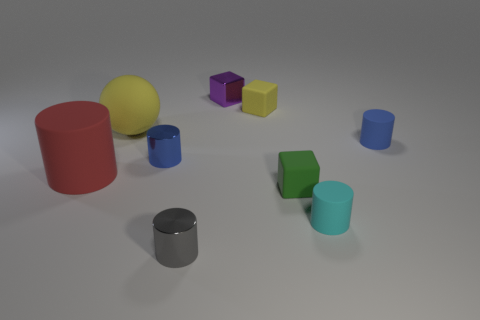There is a yellow matte thing that is in front of the tiny matte block that is behind the cylinder that is on the left side of the yellow sphere; how big is it? The yellow matte object in question appears to be of medium size compared to the other objects in the image, specifically, it is larger than the tiny blocks but smaller than the cylinders and the yellow sphere. 